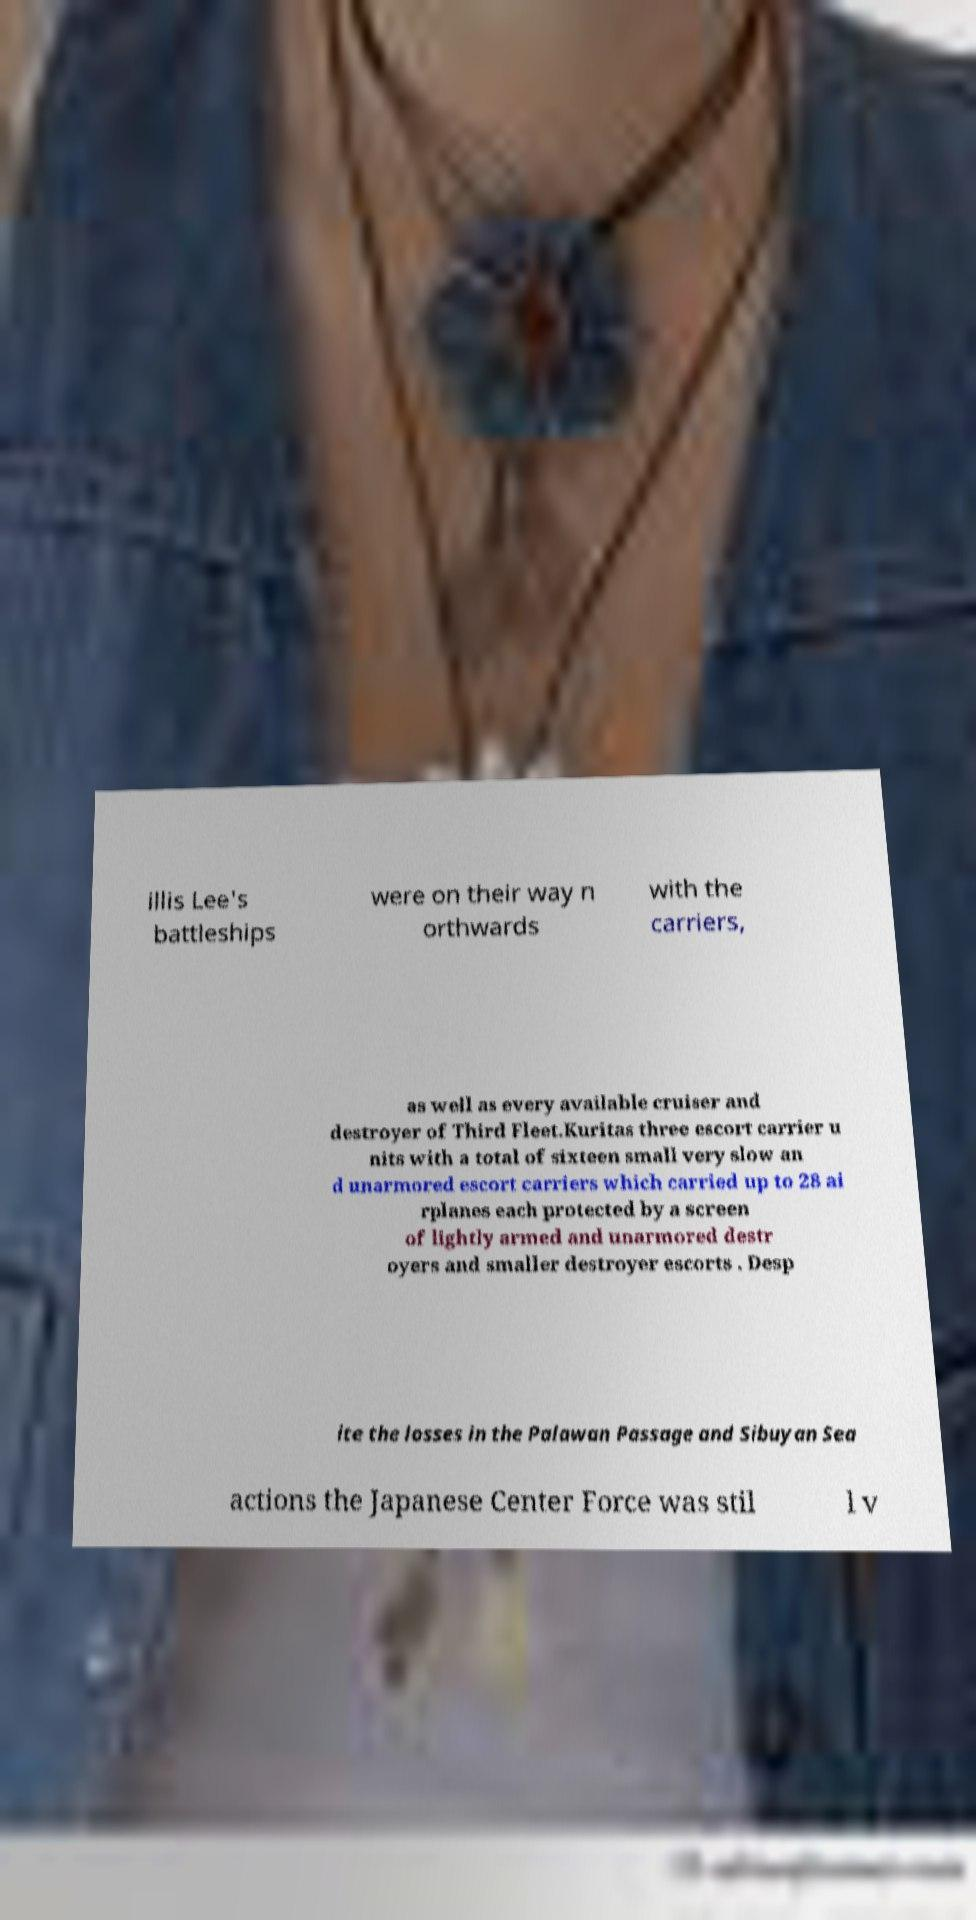Please identify and transcribe the text found in this image. illis Lee's battleships were on their way n orthwards with the carriers, as well as every available cruiser and destroyer of Third Fleet.Kuritas three escort carrier u nits with a total of sixteen small very slow an d unarmored escort carriers which carried up to 28 ai rplanes each protected by a screen of lightly armed and unarmored destr oyers and smaller destroyer escorts . Desp ite the losses in the Palawan Passage and Sibuyan Sea actions the Japanese Center Force was stil l v 